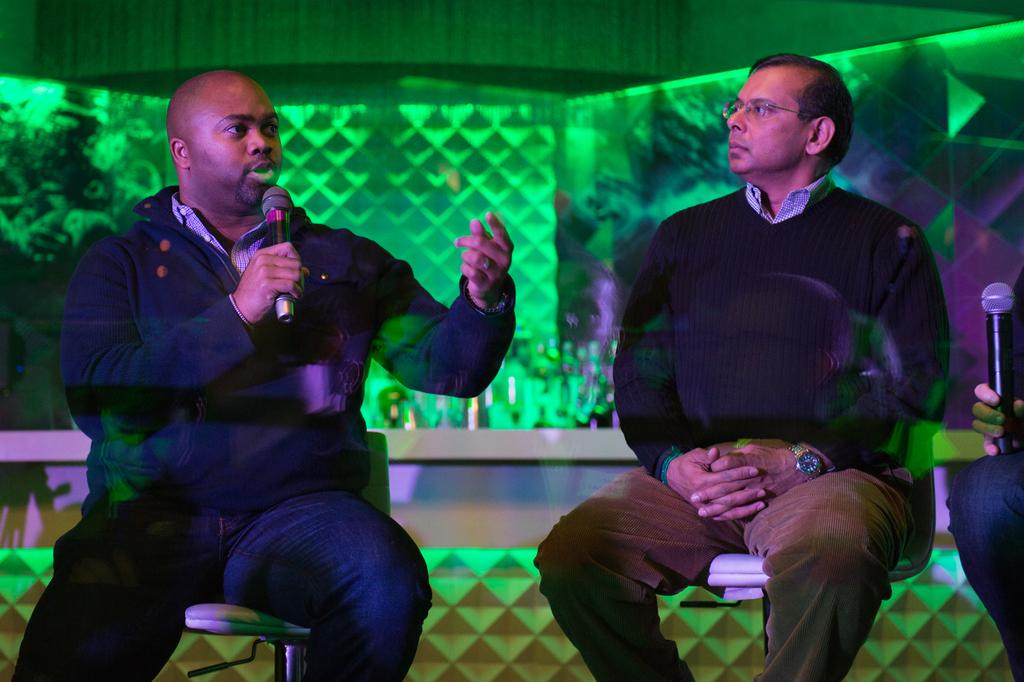How many people are sitting in the image? There are two persons sitting on chairs in the image. What is one person holding in the image? One person is holding a microphone. What type of flowers do the persons hate in the image? There are no flowers present in the image, and therefore no information about any preferences or dislikes related to flowers can be determined. 